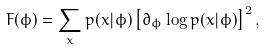<formula> <loc_0><loc_0><loc_500><loc_500>F ( \phi ) = \sum _ { x } p ( x | \phi ) \left [ \partial _ { \phi } \log p ( x | \phi ) \right ] ^ { 2 } ,</formula> 